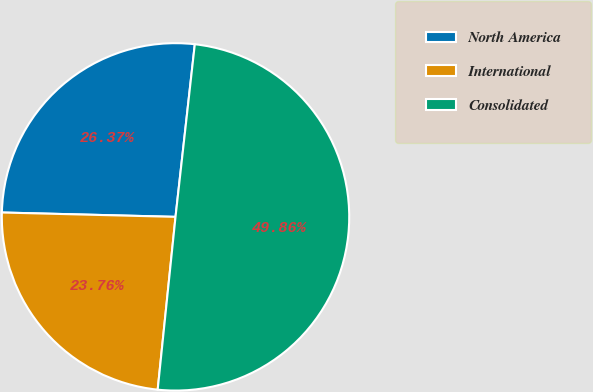Convert chart. <chart><loc_0><loc_0><loc_500><loc_500><pie_chart><fcel>North America<fcel>International<fcel>Consolidated<nl><fcel>26.37%<fcel>23.76%<fcel>49.86%<nl></chart> 